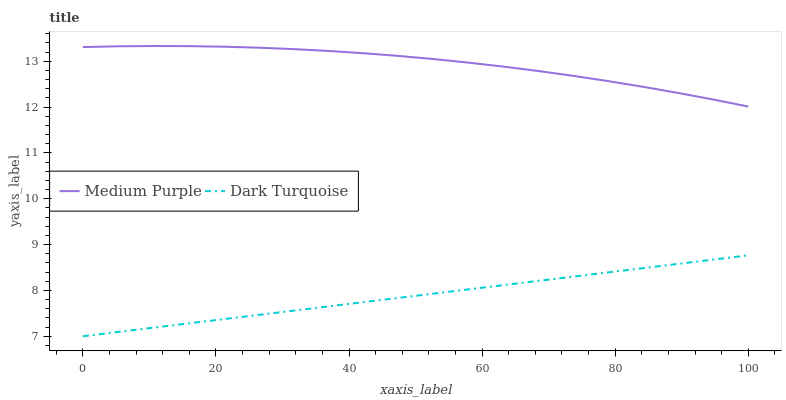Does Dark Turquoise have the minimum area under the curve?
Answer yes or no. Yes. Does Medium Purple have the maximum area under the curve?
Answer yes or no. Yes. Does Dark Turquoise have the maximum area under the curve?
Answer yes or no. No. Is Dark Turquoise the smoothest?
Answer yes or no. Yes. Is Medium Purple the roughest?
Answer yes or no. Yes. Is Dark Turquoise the roughest?
Answer yes or no. No. Does Dark Turquoise have the lowest value?
Answer yes or no. Yes. Does Medium Purple have the highest value?
Answer yes or no. Yes. Does Dark Turquoise have the highest value?
Answer yes or no. No. Is Dark Turquoise less than Medium Purple?
Answer yes or no. Yes. Is Medium Purple greater than Dark Turquoise?
Answer yes or no. Yes. Does Dark Turquoise intersect Medium Purple?
Answer yes or no. No. 